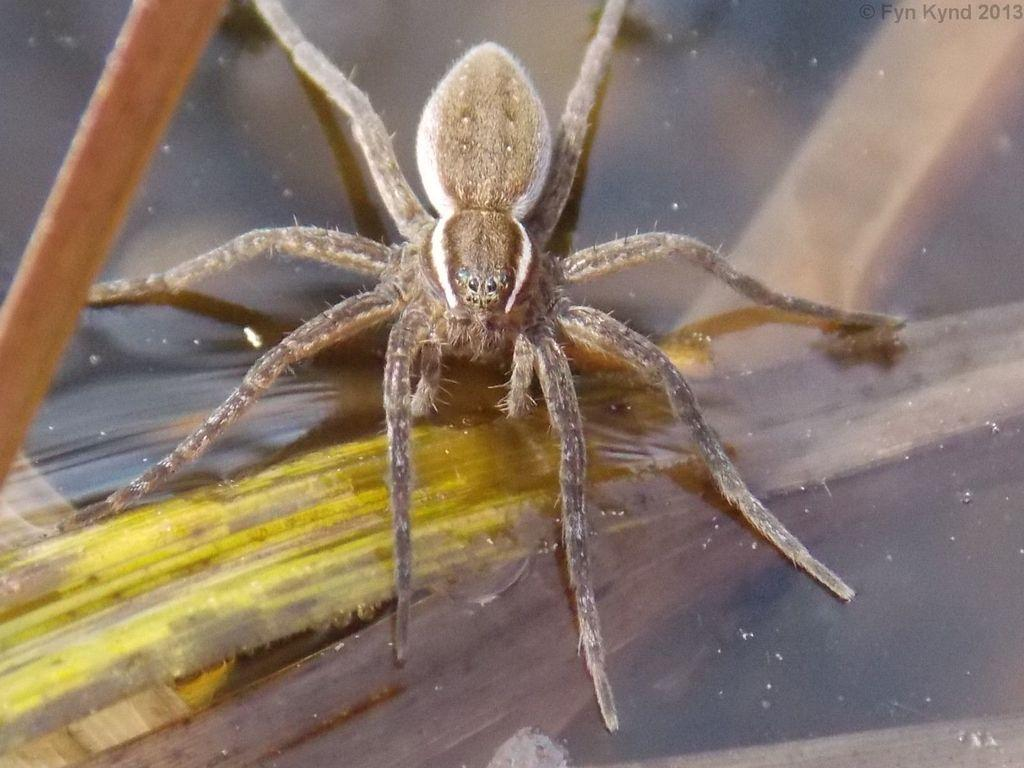What is the main subject of the image? There is a spider in the image. Where is the spider located? The spider is in a glass. What type of table is visible in the image? There is a glass table in the image. How does the beggar help the spider in the image? There is no beggar present in the image, and therefore no interaction between a beggar and the spider can be observed. 